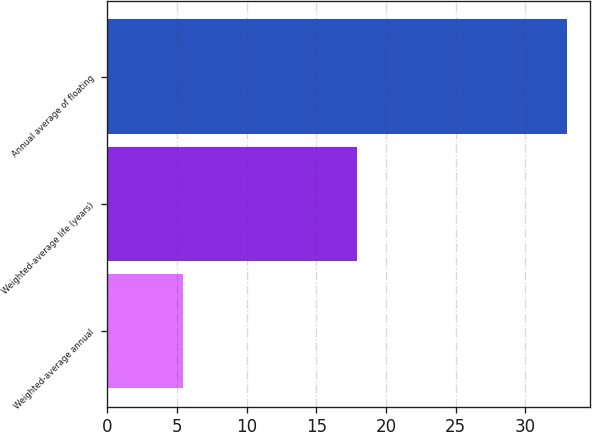<chart> <loc_0><loc_0><loc_500><loc_500><bar_chart><fcel>Weighted-average annual<fcel>Weighted-average life (years)<fcel>Annual average of floating<nl><fcel>5.4<fcel>17.9<fcel>33<nl></chart> 